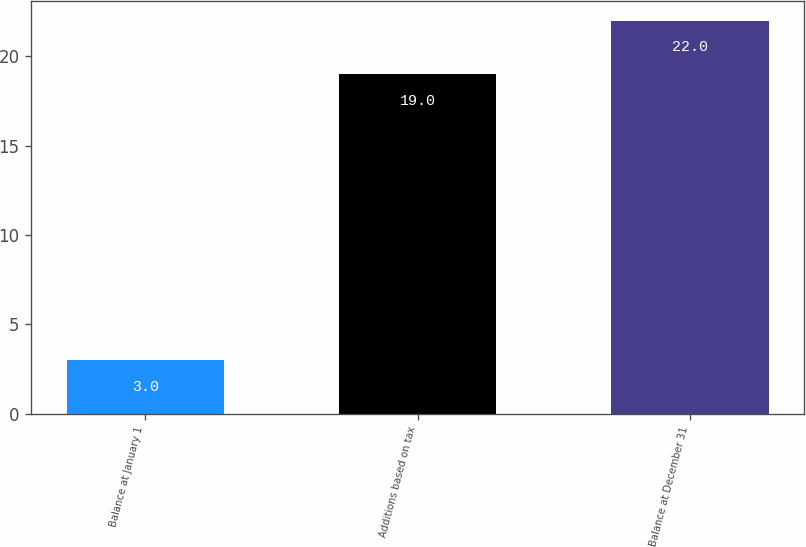<chart> <loc_0><loc_0><loc_500><loc_500><bar_chart><fcel>Balance at January 1<fcel>Additions based on tax<fcel>Balance at December 31<nl><fcel>3<fcel>19<fcel>22<nl></chart> 